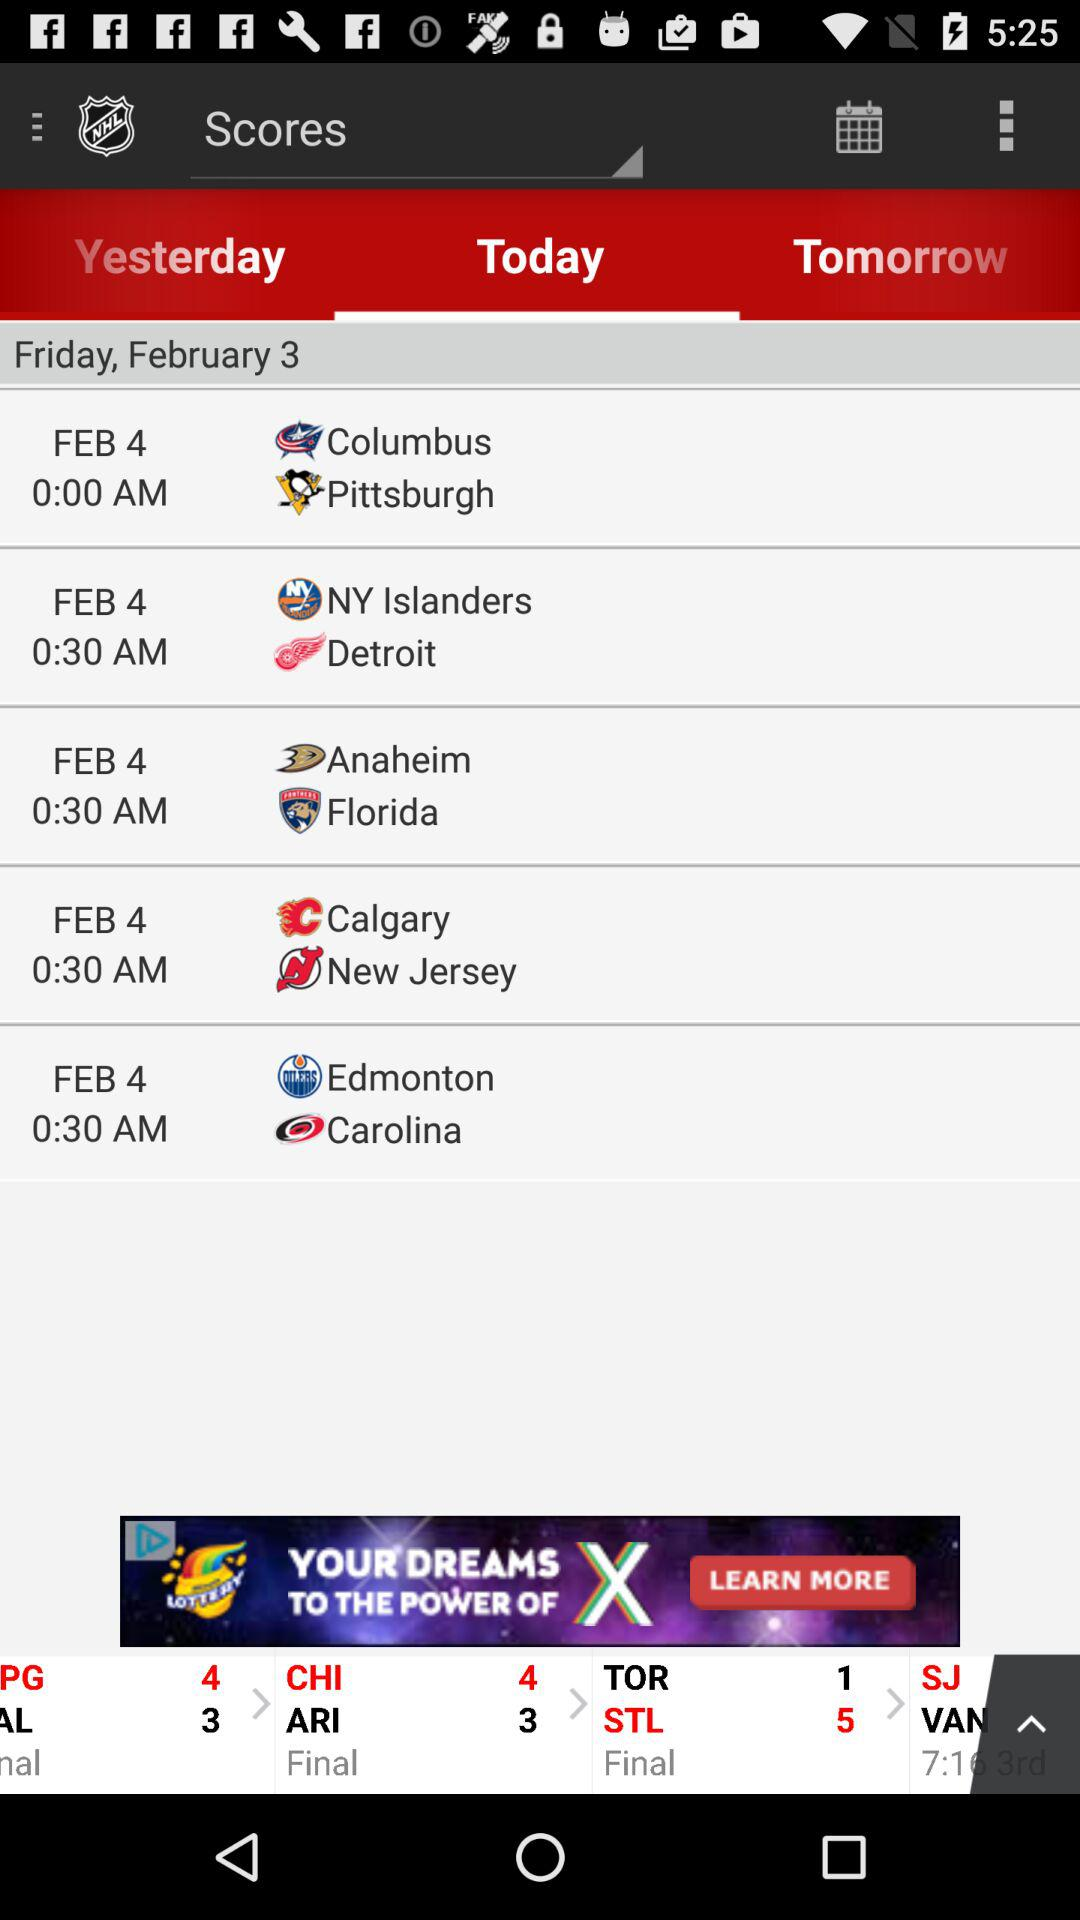What is the time of the match between "New Jersey" and "Calgary"? The time of the match is 0:30 AM. 